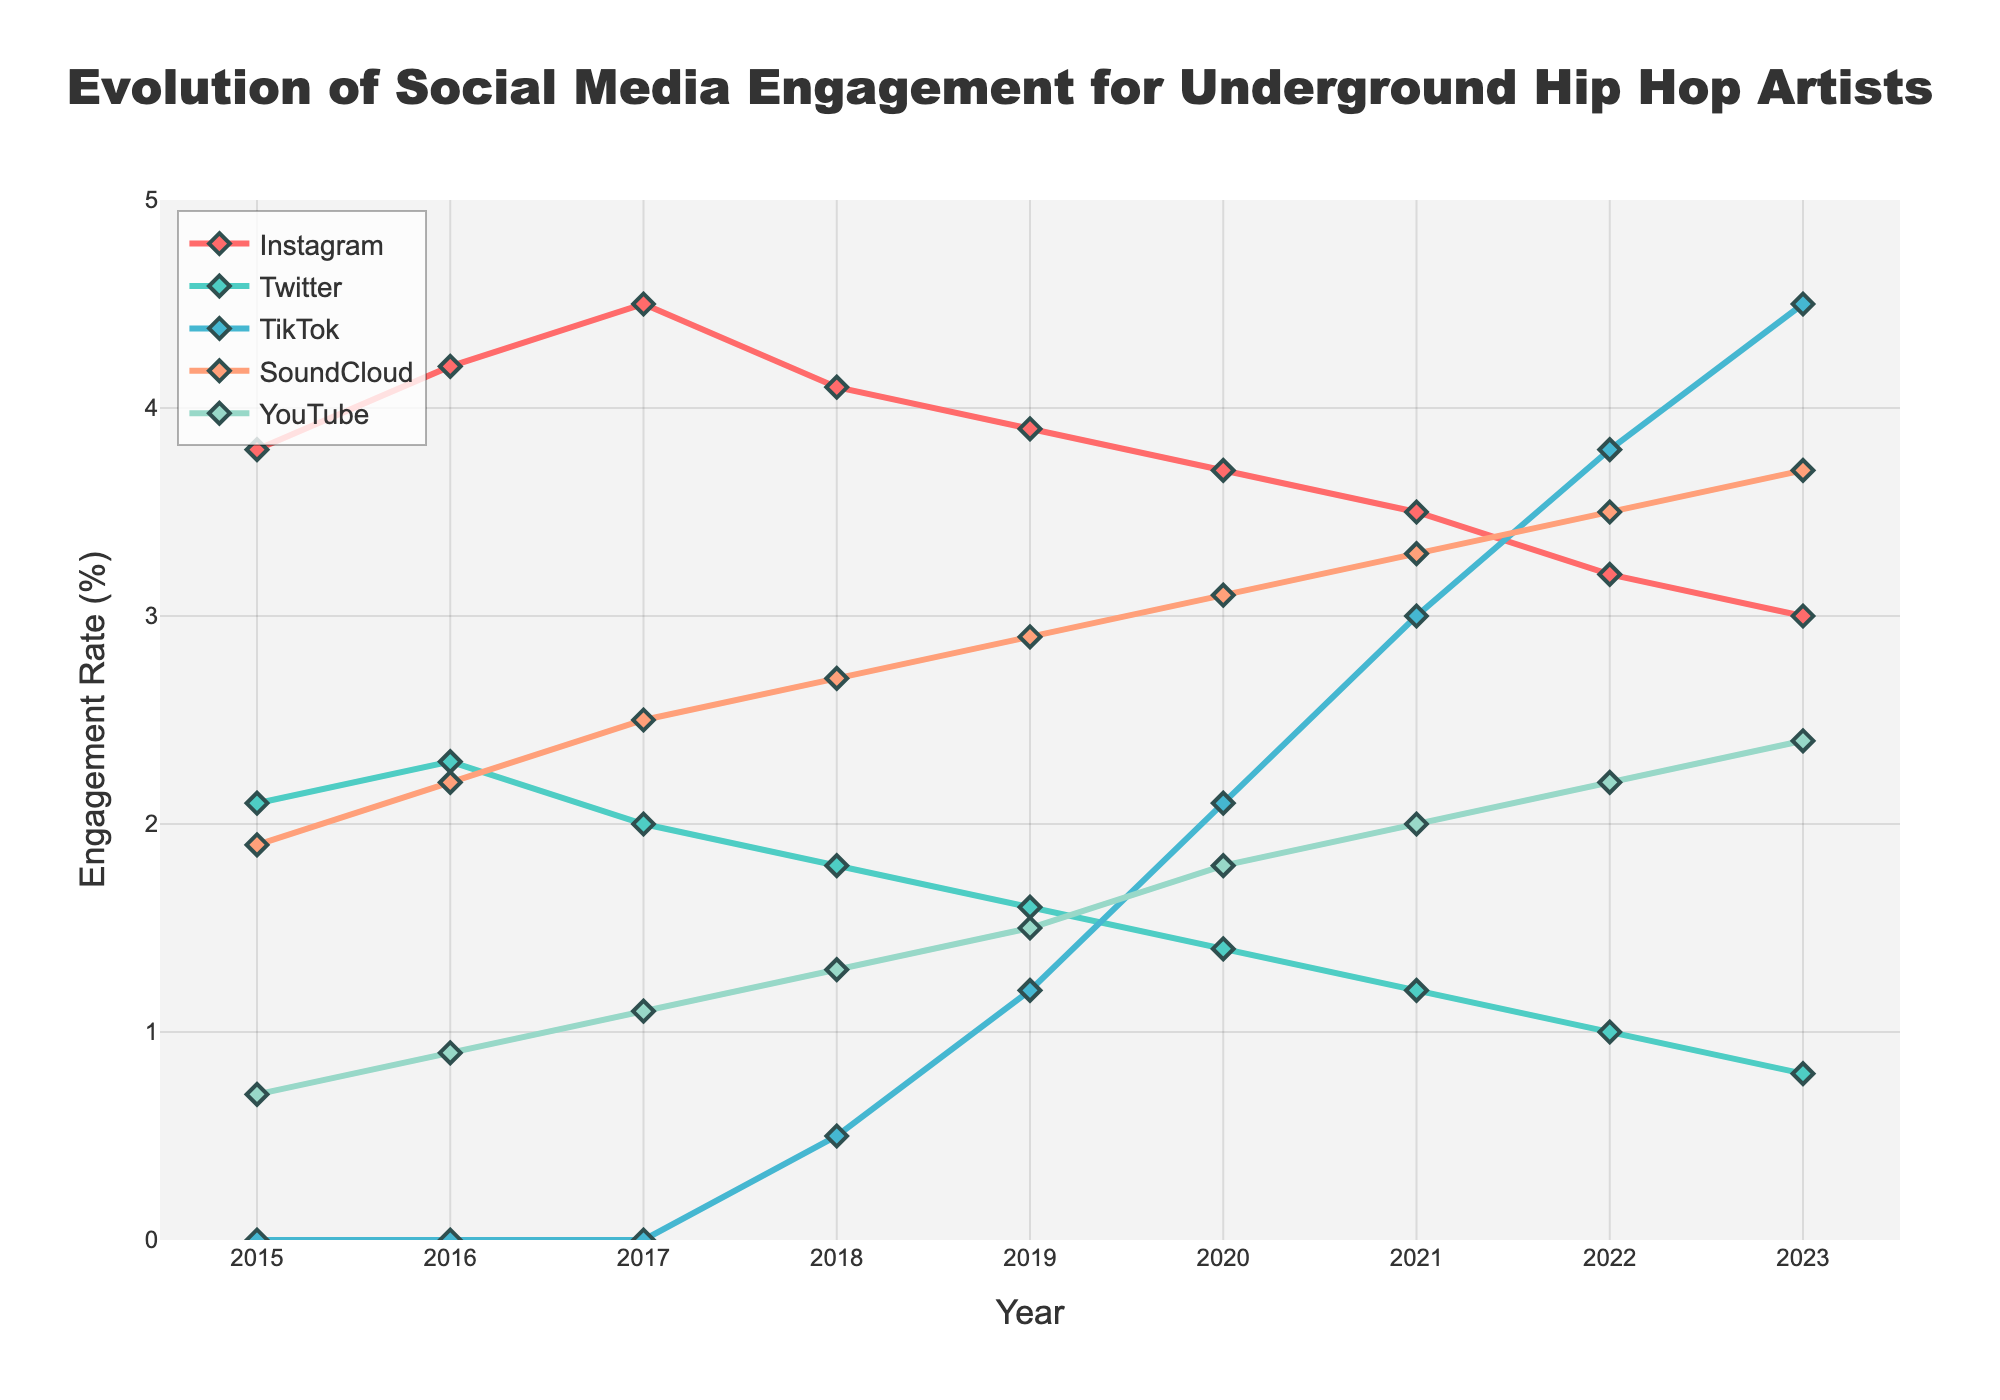What year did TikTok engagement surpass Twitter engagement? By looking at the lines representing TikTok and Twitter on the chart, we observe that TikTok's engagement rate exceeds Twitter's engagement rate starting in 2019.
Answer: 2019 Comparing Instagram and TikTok, which platform had the higher engagement rate in 2023? Observing the endpoints of the Instagram and TikTok lines for the year 2023, TikTok has an engagement rate of 4.5 while Instagram has 3.0. Thus, TikTok has the higher engagement rate.
Answer: TikTok What is the average engagement rate of SoundCloud from 2015 to 2023? To calculate this, sum the engagement rates of SoundCloud for all the years (1.9 + 2.2 + 2.5 + 2.7 + 2.9 + 3.1 + 3.3 + 3.5 + 3.7) and then divide by the number of years (9). The sum is 26.8, and dividing by 9 gives approximately 2.978.
Answer: 2.978 Which platform shows the most consistent engagement growth from 2015 to 2023? Observing the trends of all the platforms, TikTok shows the most consistent and steepest increase from its introduction in 2018 until 2023 without any decline.
Answer: TikTok Between Instagram and YouTube, which platform had a higher peak engagement and what was the value? By observing the highest points on the Instagram and YouTube lines, Instagram had a peak engagement rate of 4.5 in 2017, while YouTube's peak is lower at 2.4 in 2023.
Answer: Instagram, 4.5 What year did YouTube's engagement rate surpass 2.0? Observing the YouTube line, its engagement rate surpasses 2.0 in the year 2020 and remains above this threshold thereafter.
Answer: 2020 How did Twitter engagement change from 2015 to 2023, and what is the overall trend? Examining the Twitter line, the engagement rate decreased steadily from 2.1 in 2015 to 0.8 in 2023. The overall trend is a consistent decline.
Answer: Declined What is the difference in engagement rates between SoundCloud and TikTok in 2023? For 2023, SoundCloud has an engagement rate of 3.7 while TikTok is at 4.5. The difference is calculated as 4.5 - 3.7 = 0.8.
Answer: 0.8 Which platform had the lowest engagement rate in 2015 and what was it? Reviewing the plots for 2015, YouTube had the lowest engagement rate at 0.7.
Answer: YouTube, 0.7 What is the median engagement rate of Instagram for the shown years? Listing the engagement rates of Instagram from all years (3.8, 4.2, 4.5, 4.1, 3.9, 3.7, 3.5, 3.2, 3.0) and finding the middle value, the median is 3.8 for the ordered list.
Answer: 3.8 